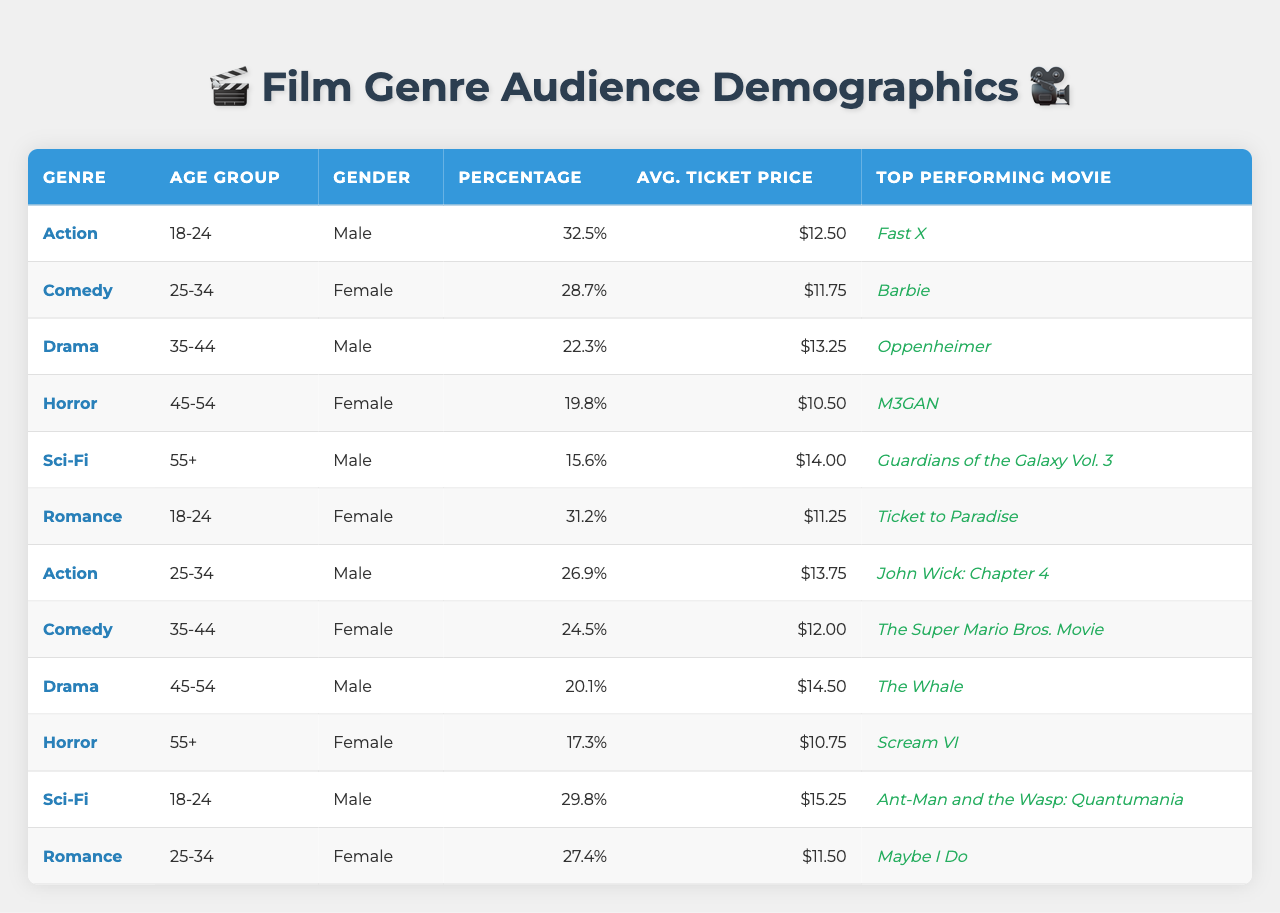What is the top performing movie in the Sci-Fi genre? The Sci-Fi genre's top performing movie is listed as "Guardians of the Galaxy Vol. 3."
Answer: Guardians of the Galaxy Vol. 3 Which age group has the highest percentage of audience for Action movies? The age group "18-24" has the highest percentage, which is 32.5%.
Answer: 18-24 What is the average ticket price for Comedy movies? The average ticket price for Comedy movies is $11.75.
Answer: $11.75 Is "M3GAN" the top performing movie for the Drama genre? No, the top performing movie for the Drama genre is "The Whale," while "M3GAN" is for Horror.
Answer: No Which gender has a higher percentage in the 45-54 age group for Horror films? The female audience has a percentage of 19.8% compared to the male audience at 20.1%. Therefore, male has a higher percentage.
Answer: Male What is the combined percentage of the 18-24 age group for Action and Romance genres? The percentage for Action in the 18-24 age group is 32.5%, and for Romance, it is 31.2%. Adding these gives 32.5 + 31.2 = 63.7%.
Answer: 63.7% Which genre has the lowest average ticket price? The Horror genre has the lowest average ticket price at $10.50.
Answer: Horror What is the median ticket price among all genres? The average ticket prices are: $12.50, $11.75, $13.25, $10.50, $14.00, $11.25, $13.75, $12.00, $14.50, $10.75, $15.25, $11.50. Arranging them, the middle values are $11.75 and $12.00, with the median being the average of 11.75 and 12.00, giving us $11.875, which rounds to $11.88.
Answer: $11.88 What is the percentage difference in the male audience between the Action and Comedy genres? The percentage for male in Action is 32.5%, and in Comedy, it is 31.2%. The difference is 32.5 - 31.2 = 1.3%.
Answer: 1.3% Identify the genre with the largest audience in the 35-44 age group. The Drama genre has a percentage of 22.3%, which is the largest in the 35-44 age group when comparing all genres.
Answer: Drama Which age group and gender combination has a ticket price greater than $14.00? The only age group and gender combination with a ticket price greater than $14.00 is the 55+ age group for Male with a ticket price of $15.25.
Answer: 55+ Male 